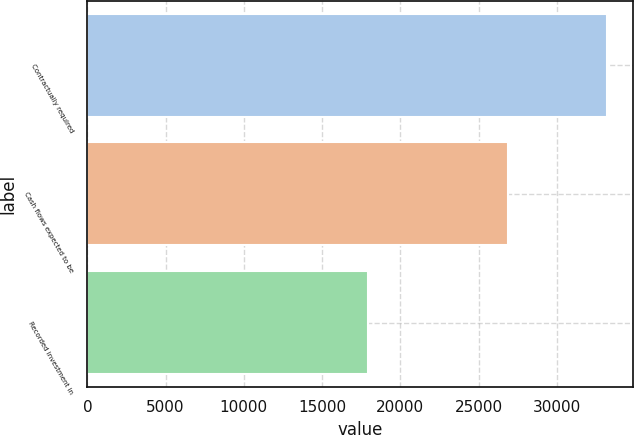Convert chart. <chart><loc_0><loc_0><loc_500><loc_500><bar_chart><fcel>Contractually required<fcel>Cash flows expected to be<fcel>Recorded investment in<nl><fcel>33191<fcel>26882<fcel>17955<nl></chart> 